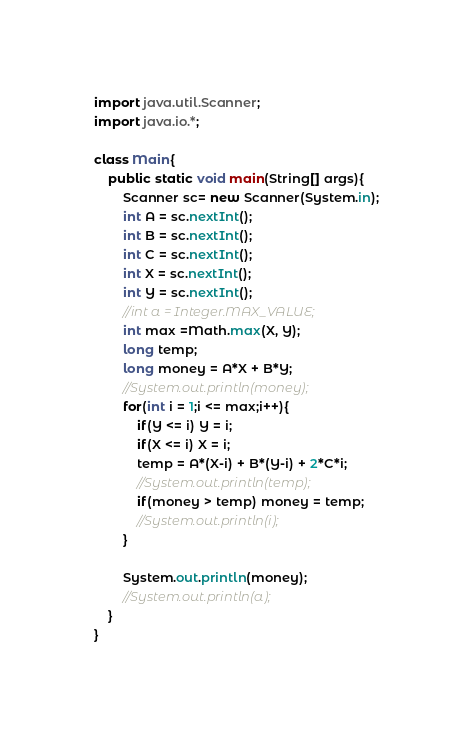<code> <loc_0><loc_0><loc_500><loc_500><_Java_>import java.util.Scanner;
import java.io.*;

class Main{
	public static void main(String[] args){
		Scanner sc= new Scanner(System.in);
		int A = sc.nextInt();
		int B = sc.nextInt();
		int C = sc.nextInt();
		int X = sc.nextInt();
		int Y = sc.nextInt();
		//int a = Integer.MAX_VALUE;
		int max =Math.max(X, Y);
		long temp;
		long money = A*X + B*Y;
		//System.out.println(money);
		for(int i = 1;i <= max;i++){
			if(Y <= i) Y = i;
			if(X <= i) X = i;
			temp = A*(X-i) + B*(Y-i) + 2*C*i;
			//System.out.println(temp);
			if(money > temp) money = temp;
			//System.out.println(i);
		}

		System.out.println(money);
		//System.out.println(a);
	}
}</code> 